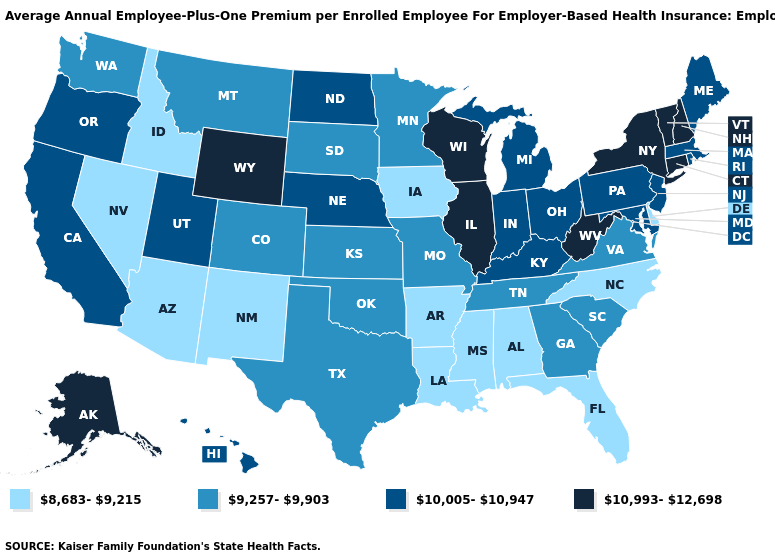What is the value of Indiana?
Concise answer only. 10,005-10,947. Among the states that border New York , does Connecticut have the highest value?
Concise answer only. Yes. What is the highest value in the Northeast ?
Answer briefly. 10,993-12,698. What is the lowest value in the USA?
Short answer required. 8,683-9,215. Name the states that have a value in the range 8,683-9,215?
Answer briefly. Alabama, Arizona, Arkansas, Delaware, Florida, Idaho, Iowa, Louisiana, Mississippi, Nevada, New Mexico, North Carolina. What is the lowest value in the Northeast?
Quick response, please. 10,005-10,947. Name the states that have a value in the range 10,005-10,947?
Write a very short answer. California, Hawaii, Indiana, Kentucky, Maine, Maryland, Massachusetts, Michigan, Nebraska, New Jersey, North Dakota, Ohio, Oregon, Pennsylvania, Rhode Island, Utah. How many symbols are there in the legend?
Keep it brief. 4. Is the legend a continuous bar?
Answer briefly. No. Is the legend a continuous bar?
Short answer required. No. What is the value of Mississippi?
Keep it brief. 8,683-9,215. Name the states that have a value in the range 10,993-12,698?
Quick response, please. Alaska, Connecticut, Illinois, New Hampshire, New York, Vermont, West Virginia, Wisconsin, Wyoming. Does the first symbol in the legend represent the smallest category?
Concise answer only. Yes. What is the value of Idaho?
Short answer required. 8,683-9,215. 